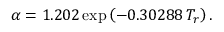<formula> <loc_0><loc_0><loc_500><loc_500>\alpha = 1 . 2 0 2 \exp \left ( - 0 . 3 0 2 8 8 \, T _ { r } \right ) .</formula> 